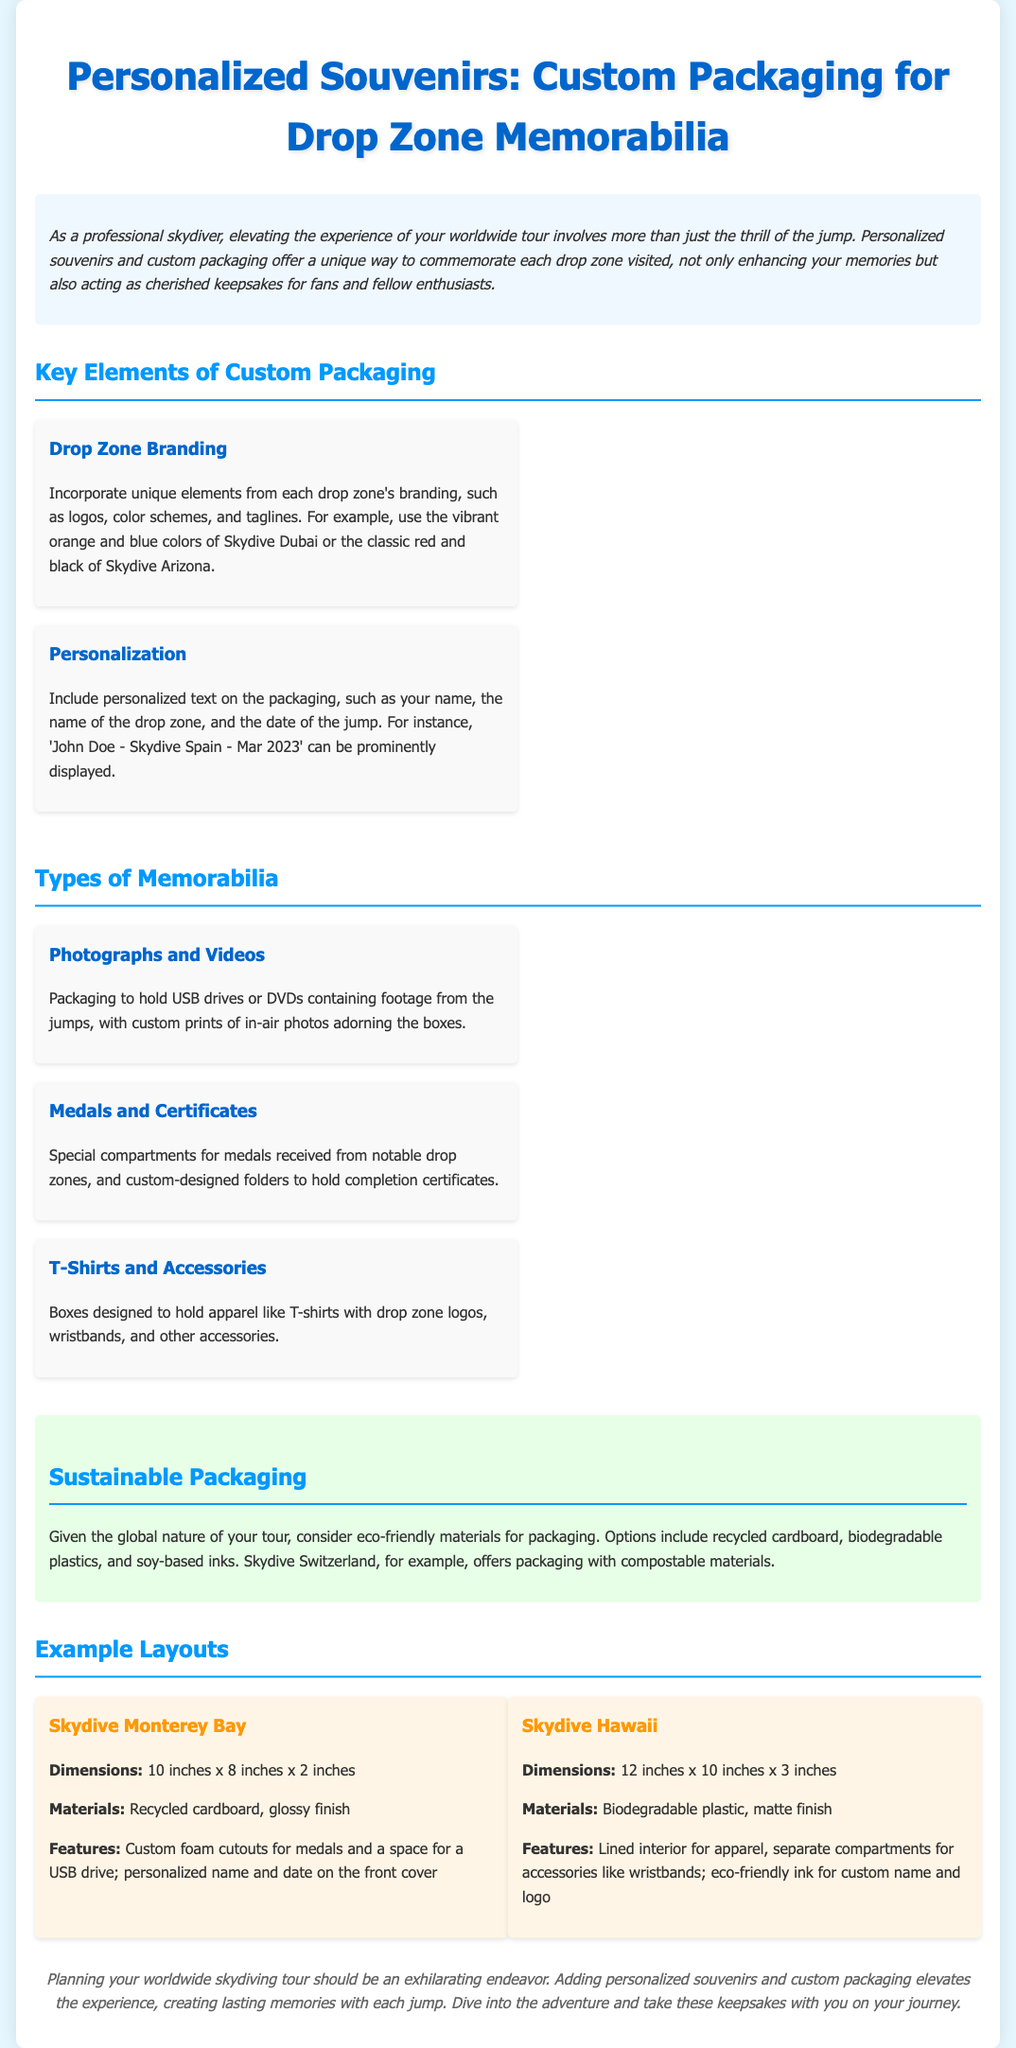What is the main theme of the document? The main theme revolves around creating personalized souvenirs and custom packaging for drop zone memorabilia for skydivers.
Answer: Personalized souvenirs What are the two key elements of custom packaging? The key elements mentioned in the document are Drop Zone Branding and Personalization.
Answer: Drop Zone Branding, Personalization What memorabilia types are discussed in the document? The types of memorabilia mentioned include Photographs and Videos, Medals and Certificates, and T-Shirts and Accessories.
Answer: Photographs and Videos, Medals and Certificates, T-Shirts and Accessories What sustainable packaging materials are suggested? The document suggests recycled cardboard, biodegradable plastics, and soy-based inks as eco-friendly packaging options.
Answer: Recycled cardboard, biodegradable plastics, soy-based inks How large is the custom packaging for Skydive Monterey Bay? The dimensions of the custom packaging for Skydive Monterey Bay are specified in the document.
Answer: 10 inches x 8 inches x 2 inches What feature is included in Skydive Hawaii's packaging? The document specifies that Skydive Hawaii's packaging includes separate compartments for accessories like wristbands.
Answer: Compartment for accessories like wristbands What personalization details are recommended for the packaging? Recommended personalization details include adding the skydiver's name, drop zone name, and jump date on the packaging.
Answer: Name, drop zone name, jump date What color scheme does Skydive Dubai use? The document cites vibrant orange and blue as the color scheme for Skydive Dubai branding.
Answer: Orange and blue 